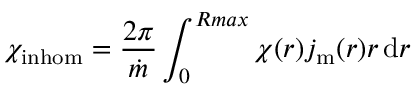Convert formula to latex. <formula><loc_0><loc_0><loc_500><loc_500>\chi _ { i n h o m } = \frac { 2 \pi } { \dot { m } } \int _ { 0 } ^ { R \max } \chi ( r ) j _ { m } ( r ) r \, d r</formula> 